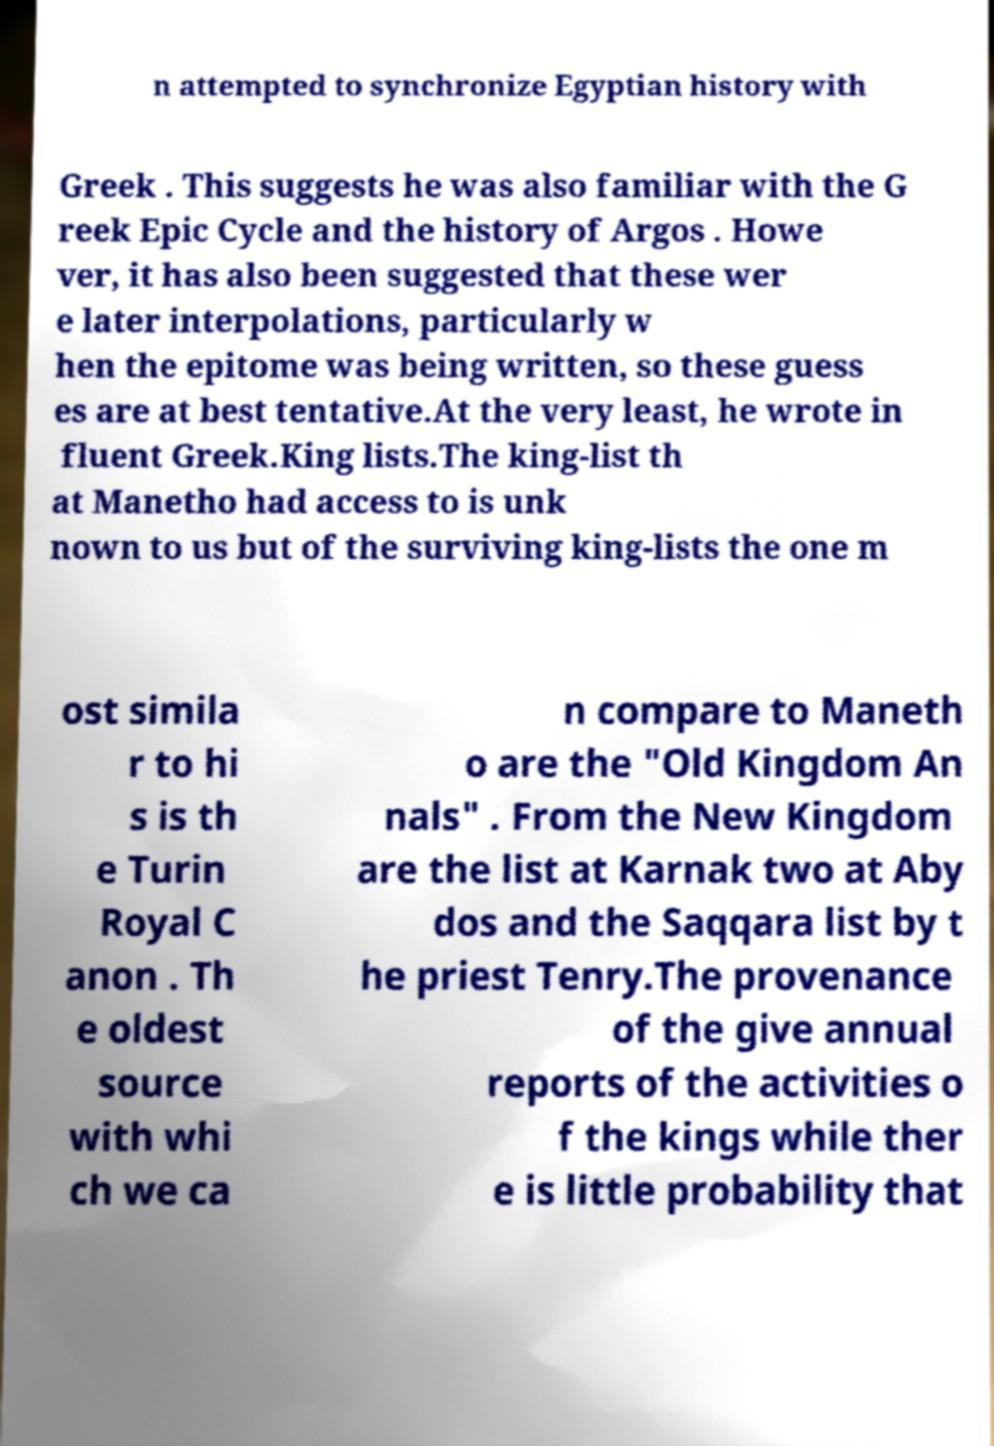Please read and relay the text visible in this image. What does it say? n attempted to synchronize Egyptian history with Greek . This suggests he was also familiar with the G reek Epic Cycle and the history of Argos . Howe ver, it has also been suggested that these wer e later interpolations, particularly w hen the epitome was being written, so these guess es are at best tentative.At the very least, he wrote in fluent Greek.King lists.The king-list th at Manetho had access to is unk nown to us but of the surviving king-lists the one m ost simila r to hi s is th e Turin Royal C anon . Th e oldest source with whi ch we ca n compare to Maneth o are the "Old Kingdom An nals" . From the New Kingdom are the list at Karnak two at Aby dos and the Saqqara list by t he priest Tenry.The provenance of the give annual reports of the activities o f the kings while ther e is little probability that 